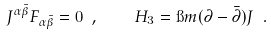Convert formula to latex. <formula><loc_0><loc_0><loc_500><loc_500>J ^ { \alpha \bar { \beta } } F _ { \alpha \bar { \beta } } = 0 \ , \quad H _ { 3 } = \i m ( \partial - \bar { \partial } ) J \ .</formula> 